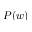Convert formula to latex. <formula><loc_0><loc_0><loc_500><loc_500>P ( w )</formula> 